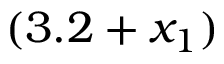<formula> <loc_0><loc_0><loc_500><loc_500>( 3 . 2 + x _ { 1 } )</formula> 